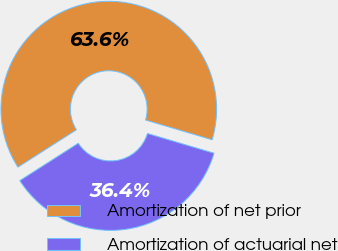Convert chart to OTSL. <chart><loc_0><loc_0><loc_500><loc_500><pie_chart><fcel>Amortization of net prior<fcel>Amortization of actuarial net<nl><fcel>63.64%<fcel>36.36%<nl></chart> 